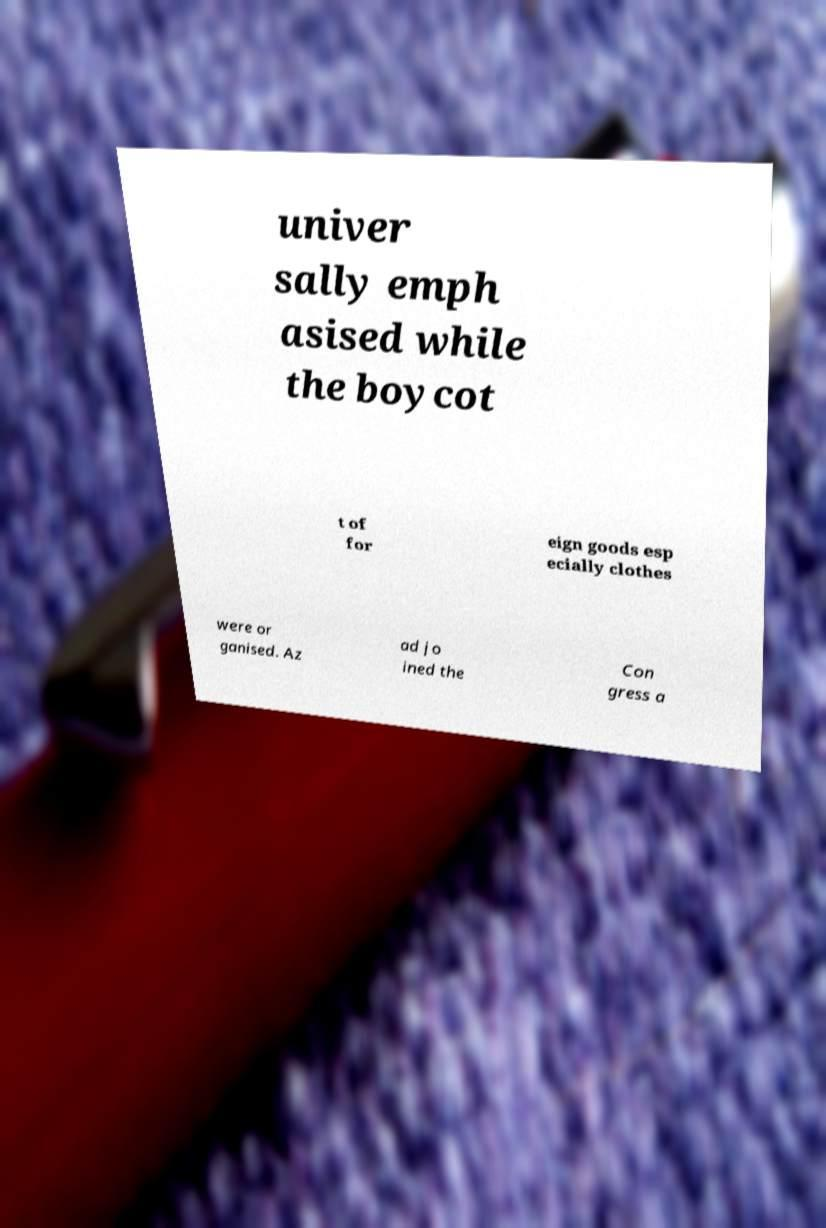Please identify and transcribe the text found in this image. univer sally emph asised while the boycot t of for eign goods esp ecially clothes were or ganised. Az ad jo ined the Con gress a 